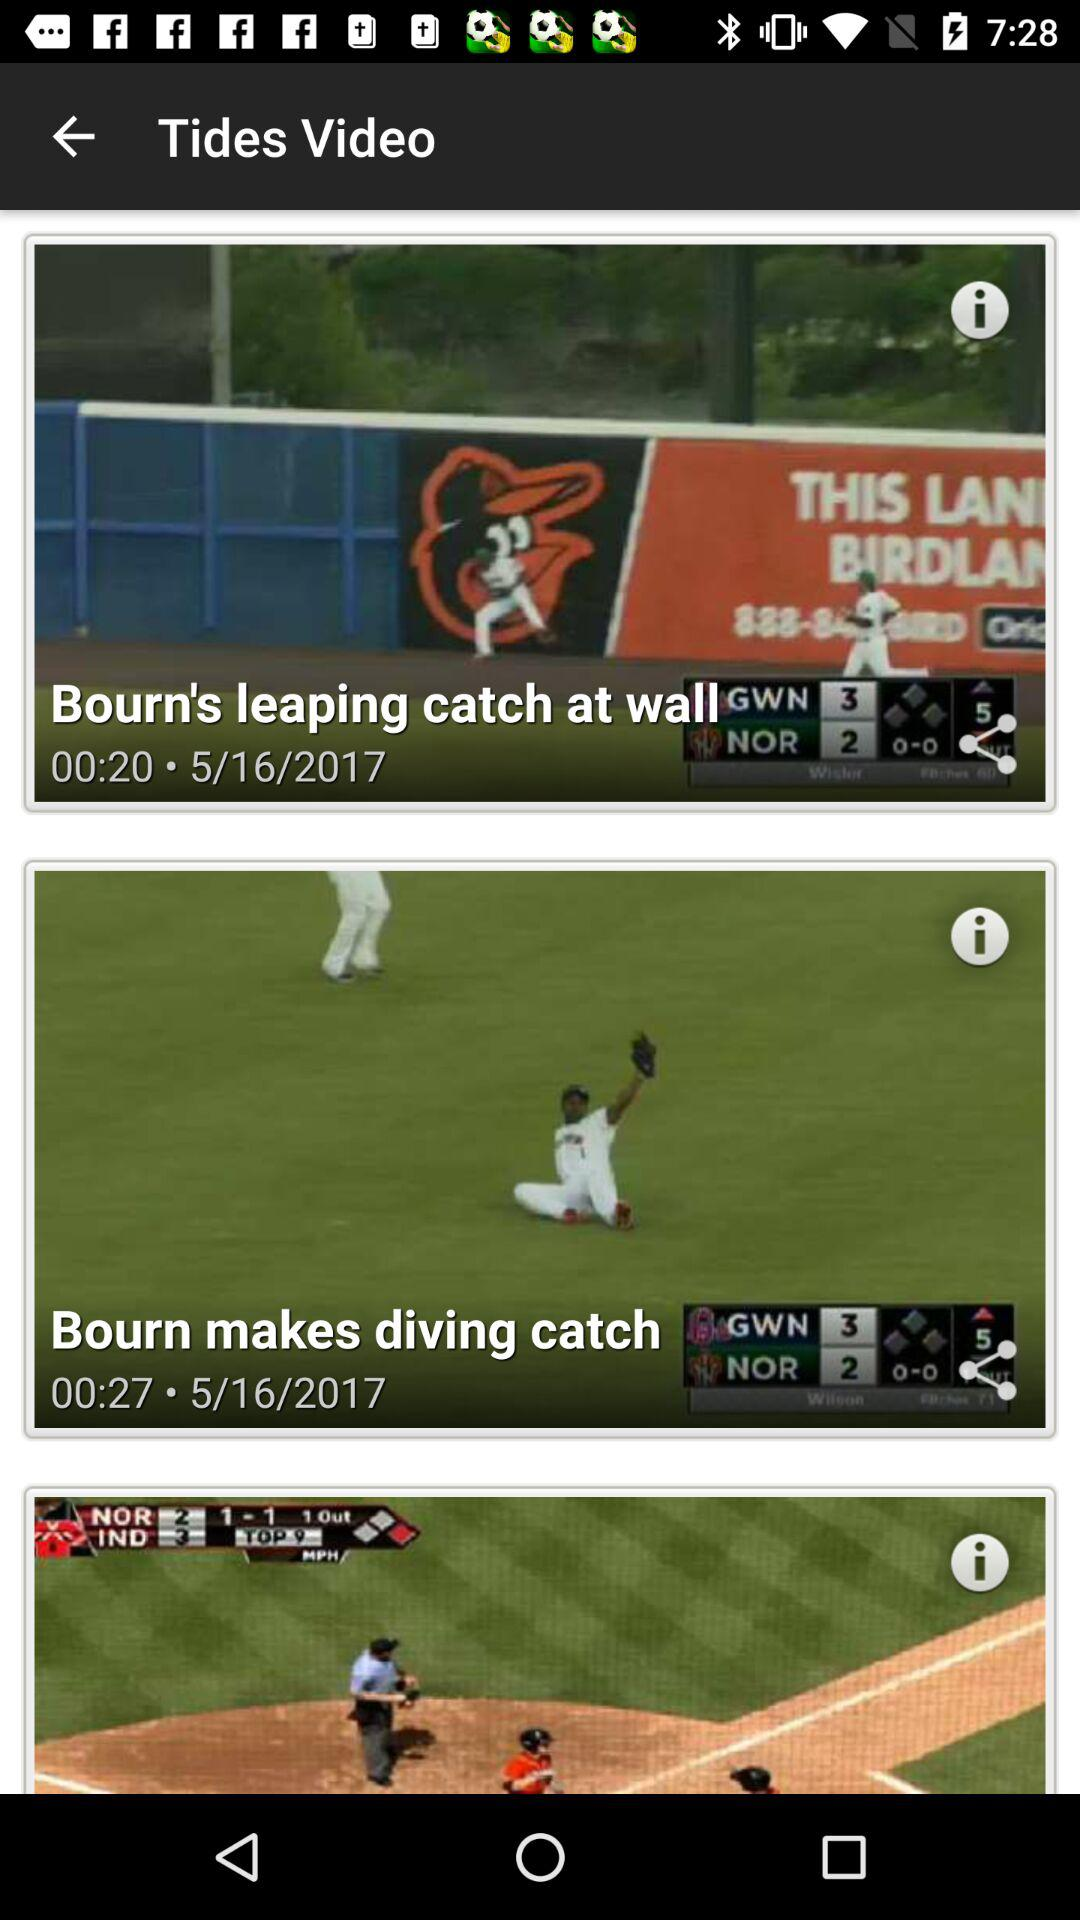What is the duration of Bourn's leaping catch at wall? The duration is 20 seconds. 